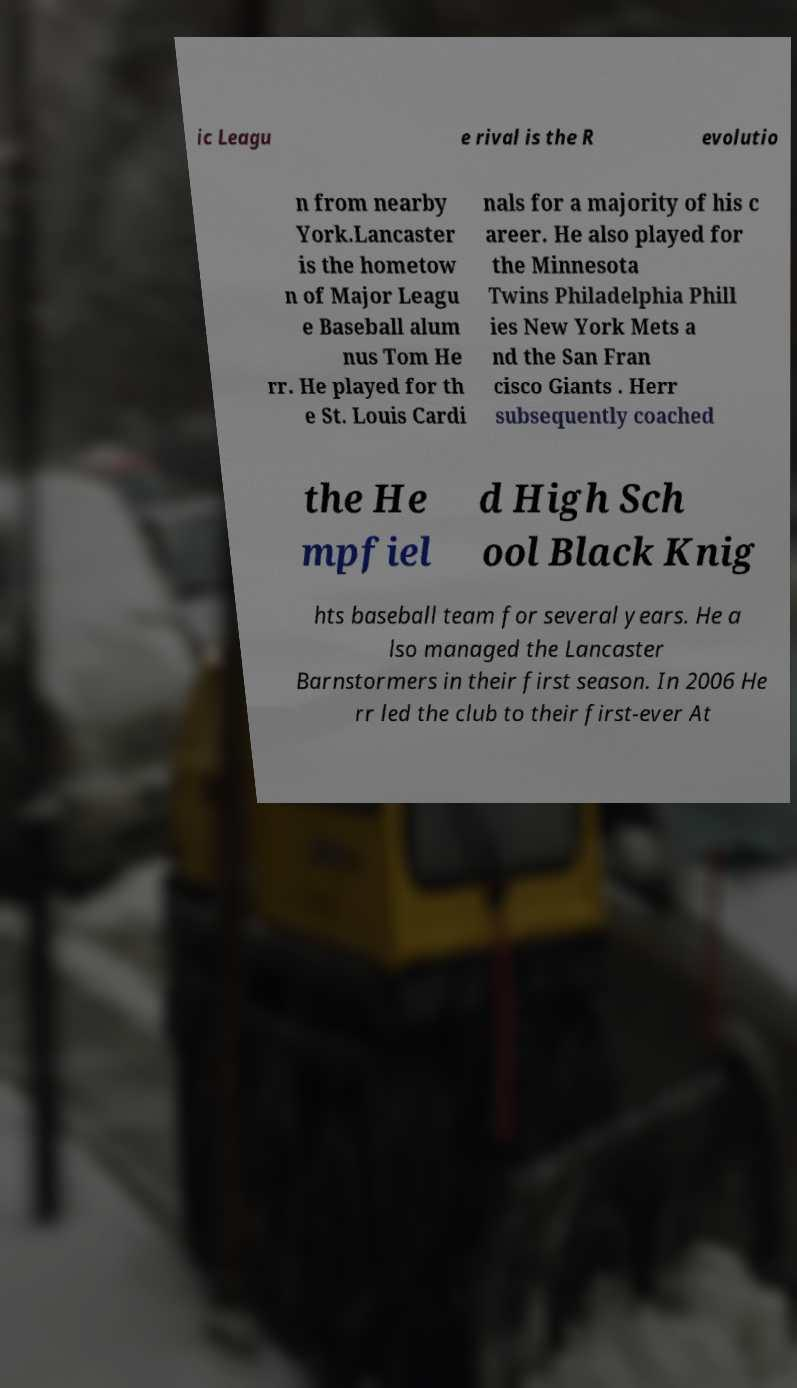What messages or text are displayed in this image? I need them in a readable, typed format. ic Leagu e rival is the R evolutio n from nearby York.Lancaster is the hometow n of Major Leagu e Baseball alum nus Tom He rr. He played for th e St. Louis Cardi nals for a majority of his c areer. He also played for the Minnesota Twins Philadelphia Phill ies New York Mets a nd the San Fran cisco Giants . Herr subsequently coached the He mpfiel d High Sch ool Black Knig hts baseball team for several years. He a lso managed the Lancaster Barnstormers in their first season. In 2006 He rr led the club to their first-ever At 